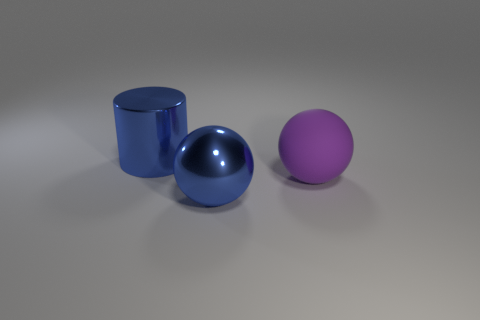How many other things are there of the same size as the blue metal cylinder?
Give a very brief answer. 2. What number of things are to the left of the purple sphere and behind the blue metallic sphere?
Your answer should be very brief. 1. Does the metallic cylinder have the same size as the rubber ball?
Provide a succinct answer. Yes. Is the size of the sphere that is in front of the purple rubber thing the same as the big purple matte sphere?
Provide a short and direct response. Yes. The big object behind the large purple sphere is what color?
Provide a succinct answer. Blue. What number of large things are there?
Ensure brevity in your answer.  3. There is a large object that is made of the same material as the big cylinder; what shape is it?
Ensure brevity in your answer.  Sphere. There is a big ball that is in front of the large purple matte thing; is it the same color as the large metallic thing that is behind the purple matte thing?
Your answer should be very brief. Yes. Are there the same number of large blue shiny cylinders behind the metal cylinder and cyan balls?
Provide a succinct answer. Yes. What number of purple spheres are on the right side of the large cylinder?
Provide a succinct answer. 1. 